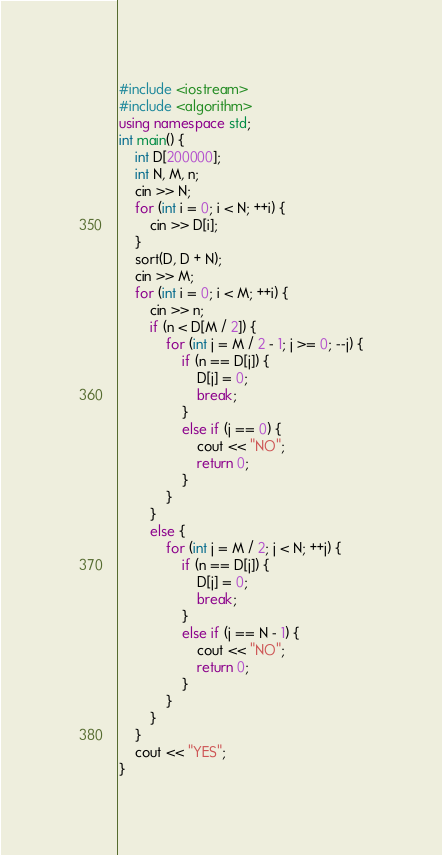Convert code to text. <code><loc_0><loc_0><loc_500><loc_500><_C++_>#include <iostream>
#include <algorithm>
using namespace std;
int main() {
	int D[200000];
	int N, M, n;
	cin >> N;
	for (int i = 0; i < N; ++i) {
		cin >> D[i];
	}
	sort(D, D + N);
	cin >> M;
	for (int i = 0; i < M; ++i) {
		cin >> n;
		if (n < D[M / 2]) {
			for (int j = M / 2 - 1; j >= 0; --j) {
				if (n == D[j]) {
					D[j] = 0;
					break;
				}
				else if (j == 0) {
					cout << "NO";
					return 0;
				}
			}
		}
		else {
			for (int j = M / 2; j < N; ++j) {
				if (n == D[j]) {
					D[j] = 0;
					break;
				}
				else if (j == N - 1) {
					cout << "NO";
					return 0;
				}
			}
		}
	}
	cout << "YES";
}</code> 